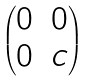<formula> <loc_0><loc_0><loc_500><loc_500>\begin{pmatrix} 0 & 0 \\ 0 & c \end{pmatrix}</formula> 